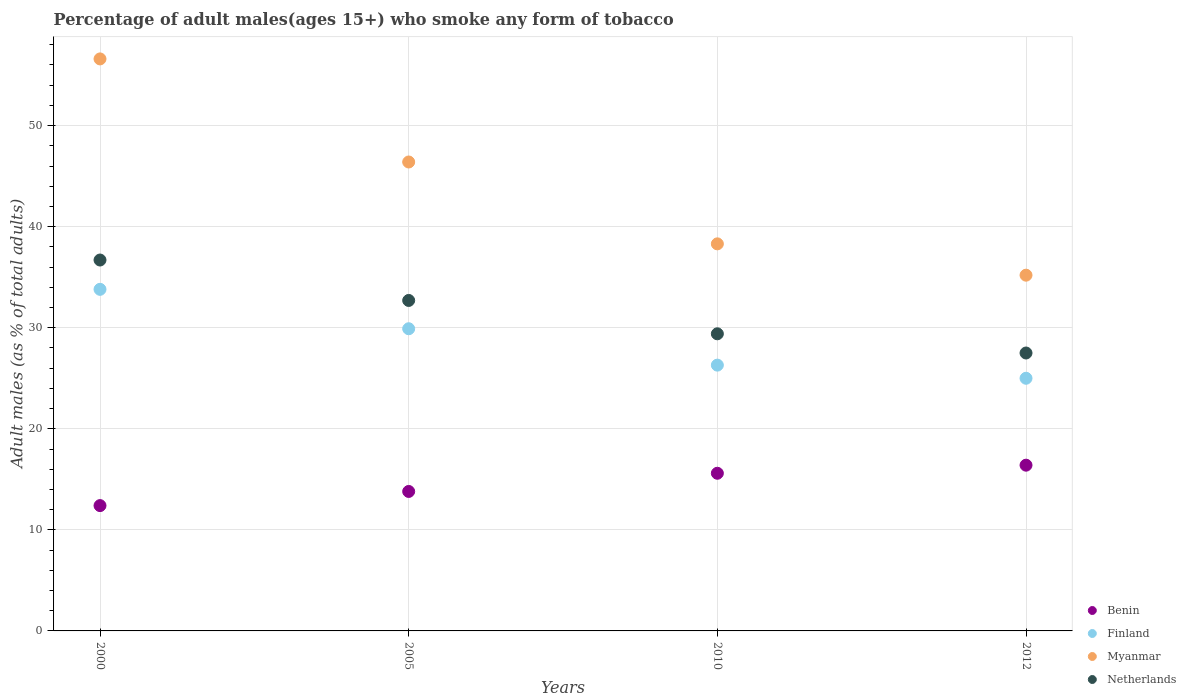How many different coloured dotlines are there?
Your answer should be compact. 4. Is the number of dotlines equal to the number of legend labels?
Give a very brief answer. Yes. What is the percentage of adult males who smoke in Finland in 2005?
Make the answer very short. 29.9. Across all years, what is the maximum percentage of adult males who smoke in Benin?
Your answer should be compact. 16.4. Across all years, what is the minimum percentage of adult males who smoke in Finland?
Offer a terse response. 25. In which year was the percentage of adult males who smoke in Finland minimum?
Provide a short and direct response. 2012. What is the total percentage of adult males who smoke in Finland in the graph?
Your response must be concise. 115. What is the difference between the percentage of adult males who smoke in Myanmar in 2010 and that in 2012?
Offer a terse response. 3.1. What is the difference between the percentage of adult males who smoke in Finland in 2000 and the percentage of adult males who smoke in Myanmar in 2012?
Provide a short and direct response. -1.4. What is the average percentage of adult males who smoke in Netherlands per year?
Your response must be concise. 31.58. In the year 2005, what is the difference between the percentage of adult males who smoke in Benin and percentage of adult males who smoke in Myanmar?
Offer a very short reply. -32.6. In how many years, is the percentage of adult males who smoke in Finland greater than 20 %?
Your response must be concise. 4. What is the ratio of the percentage of adult males who smoke in Netherlands in 2000 to that in 2010?
Your answer should be very brief. 1.25. Is the difference between the percentage of adult males who smoke in Benin in 2000 and 2005 greater than the difference between the percentage of adult males who smoke in Myanmar in 2000 and 2005?
Provide a succinct answer. No. What is the difference between the highest and the second highest percentage of adult males who smoke in Finland?
Provide a succinct answer. 3.9. What is the difference between the highest and the lowest percentage of adult males who smoke in Finland?
Your answer should be compact. 8.8. Is the sum of the percentage of adult males who smoke in Netherlands in 2005 and 2012 greater than the maximum percentage of adult males who smoke in Finland across all years?
Provide a short and direct response. Yes. Does the percentage of adult males who smoke in Netherlands monotonically increase over the years?
Provide a short and direct response. No. How many years are there in the graph?
Give a very brief answer. 4. What is the difference between two consecutive major ticks on the Y-axis?
Your answer should be compact. 10. Are the values on the major ticks of Y-axis written in scientific E-notation?
Keep it short and to the point. No. Where does the legend appear in the graph?
Give a very brief answer. Bottom right. How many legend labels are there?
Your answer should be very brief. 4. What is the title of the graph?
Offer a terse response. Percentage of adult males(ages 15+) who smoke any form of tobacco. What is the label or title of the Y-axis?
Provide a short and direct response. Adult males (as % of total adults). What is the Adult males (as % of total adults) of Finland in 2000?
Provide a succinct answer. 33.8. What is the Adult males (as % of total adults) of Myanmar in 2000?
Provide a succinct answer. 56.6. What is the Adult males (as % of total adults) of Netherlands in 2000?
Ensure brevity in your answer.  36.7. What is the Adult males (as % of total adults) of Finland in 2005?
Provide a short and direct response. 29.9. What is the Adult males (as % of total adults) in Myanmar in 2005?
Ensure brevity in your answer.  46.4. What is the Adult males (as % of total adults) of Netherlands in 2005?
Your answer should be compact. 32.7. What is the Adult males (as % of total adults) of Benin in 2010?
Ensure brevity in your answer.  15.6. What is the Adult males (as % of total adults) in Finland in 2010?
Give a very brief answer. 26.3. What is the Adult males (as % of total adults) in Myanmar in 2010?
Offer a very short reply. 38.3. What is the Adult males (as % of total adults) in Netherlands in 2010?
Offer a terse response. 29.4. What is the Adult males (as % of total adults) in Myanmar in 2012?
Give a very brief answer. 35.2. What is the Adult males (as % of total adults) of Netherlands in 2012?
Keep it short and to the point. 27.5. Across all years, what is the maximum Adult males (as % of total adults) in Finland?
Your answer should be very brief. 33.8. Across all years, what is the maximum Adult males (as % of total adults) of Myanmar?
Keep it short and to the point. 56.6. Across all years, what is the maximum Adult males (as % of total adults) in Netherlands?
Provide a short and direct response. 36.7. Across all years, what is the minimum Adult males (as % of total adults) in Benin?
Your response must be concise. 12.4. Across all years, what is the minimum Adult males (as % of total adults) of Finland?
Provide a short and direct response. 25. Across all years, what is the minimum Adult males (as % of total adults) in Myanmar?
Give a very brief answer. 35.2. What is the total Adult males (as % of total adults) in Benin in the graph?
Provide a short and direct response. 58.2. What is the total Adult males (as % of total adults) of Finland in the graph?
Give a very brief answer. 115. What is the total Adult males (as % of total adults) in Myanmar in the graph?
Ensure brevity in your answer.  176.5. What is the total Adult males (as % of total adults) of Netherlands in the graph?
Make the answer very short. 126.3. What is the difference between the Adult males (as % of total adults) of Finland in 2000 and that in 2005?
Your answer should be compact. 3.9. What is the difference between the Adult males (as % of total adults) of Myanmar in 2000 and that in 2005?
Provide a short and direct response. 10.2. What is the difference between the Adult males (as % of total adults) in Netherlands in 2000 and that in 2005?
Keep it short and to the point. 4. What is the difference between the Adult males (as % of total adults) in Netherlands in 2000 and that in 2010?
Your answer should be very brief. 7.3. What is the difference between the Adult males (as % of total adults) in Myanmar in 2000 and that in 2012?
Offer a very short reply. 21.4. What is the difference between the Adult males (as % of total adults) of Myanmar in 2005 and that in 2010?
Your answer should be very brief. 8.1. What is the difference between the Adult males (as % of total adults) of Benin in 2005 and that in 2012?
Give a very brief answer. -2.6. What is the difference between the Adult males (as % of total adults) in Benin in 2010 and that in 2012?
Your answer should be compact. -0.8. What is the difference between the Adult males (as % of total adults) of Finland in 2010 and that in 2012?
Your answer should be compact. 1.3. What is the difference between the Adult males (as % of total adults) of Netherlands in 2010 and that in 2012?
Make the answer very short. 1.9. What is the difference between the Adult males (as % of total adults) of Benin in 2000 and the Adult males (as % of total adults) of Finland in 2005?
Ensure brevity in your answer.  -17.5. What is the difference between the Adult males (as % of total adults) in Benin in 2000 and the Adult males (as % of total adults) in Myanmar in 2005?
Give a very brief answer. -34. What is the difference between the Adult males (as % of total adults) of Benin in 2000 and the Adult males (as % of total adults) of Netherlands in 2005?
Offer a terse response. -20.3. What is the difference between the Adult males (as % of total adults) in Finland in 2000 and the Adult males (as % of total adults) in Netherlands in 2005?
Keep it short and to the point. 1.1. What is the difference between the Adult males (as % of total adults) of Myanmar in 2000 and the Adult males (as % of total adults) of Netherlands in 2005?
Provide a succinct answer. 23.9. What is the difference between the Adult males (as % of total adults) of Benin in 2000 and the Adult males (as % of total adults) of Myanmar in 2010?
Your answer should be very brief. -25.9. What is the difference between the Adult males (as % of total adults) of Finland in 2000 and the Adult males (as % of total adults) of Myanmar in 2010?
Offer a very short reply. -4.5. What is the difference between the Adult males (as % of total adults) in Finland in 2000 and the Adult males (as % of total adults) in Netherlands in 2010?
Offer a very short reply. 4.4. What is the difference between the Adult males (as % of total adults) of Myanmar in 2000 and the Adult males (as % of total adults) of Netherlands in 2010?
Your answer should be very brief. 27.2. What is the difference between the Adult males (as % of total adults) in Benin in 2000 and the Adult males (as % of total adults) in Myanmar in 2012?
Your response must be concise. -22.8. What is the difference between the Adult males (as % of total adults) of Benin in 2000 and the Adult males (as % of total adults) of Netherlands in 2012?
Your response must be concise. -15.1. What is the difference between the Adult males (as % of total adults) of Finland in 2000 and the Adult males (as % of total adults) of Netherlands in 2012?
Your response must be concise. 6.3. What is the difference between the Adult males (as % of total adults) in Myanmar in 2000 and the Adult males (as % of total adults) in Netherlands in 2012?
Ensure brevity in your answer.  29.1. What is the difference between the Adult males (as % of total adults) in Benin in 2005 and the Adult males (as % of total adults) in Finland in 2010?
Your answer should be very brief. -12.5. What is the difference between the Adult males (as % of total adults) of Benin in 2005 and the Adult males (as % of total adults) of Myanmar in 2010?
Offer a very short reply. -24.5. What is the difference between the Adult males (as % of total adults) in Benin in 2005 and the Adult males (as % of total adults) in Netherlands in 2010?
Your answer should be very brief. -15.6. What is the difference between the Adult males (as % of total adults) of Finland in 2005 and the Adult males (as % of total adults) of Myanmar in 2010?
Give a very brief answer. -8.4. What is the difference between the Adult males (as % of total adults) in Myanmar in 2005 and the Adult males (as % of total adults) in Netherlands in 2010?
Your response must be concise. 17. What is the difference between the Adult males (as % of total adults) of Benin in 2005 and the Adult males (as % of total adults) of Finland in 2012?
Make the answer very short. -11.2. What is the difference between the Adult males (as % of total adults) in Benin in 2005 and the Adult males (as % of total adults) in Myanmar in 2012?
Offer a very short reply. -21.4. What is the difference between the Adult males (as % of total adults) of Benin in 2005 and the Adult males (as % of total adults) of Netherlands in 2012?
Make the answer very short. -13.7. What is the difference between the Adult males (as % of total adults) of Benin in 2010 and the Adult males (as % of total adults) of Myanmar in 2012?
Provide a short and direct response. -19.6. What is the difference between the Adult males (as % of total adults) of Finland in 2010 and the Adult males (as % of total adults) of Myanmar in 2012?
Keep it short and to the point. -8.9. What is the difference between the Adult males (as % of total adults) of Myanmar in 2010 and the Adult males (as % of total adults) of Netherlands in 2012?
Provide a short and direct response. 10.8. What is the average Adult males (as % of total adults) of Benin per year?
Ensure brevity in your answer.  14.55. What is the average Adult males (as % of total adults) in Finland per year?
Offer a very short reply. 28.75. What is the average Adult males (as % of total adults) of Myanmar per year?
Offer a terse response. 44.12. What is the average Adult males (as % of total adults) in Netherlands per year?
Offer a very short reply. 31.57. In the year 2000, what is the difference between the Adult males (as % of total adults) of Benin and Adult males (as % of total adults) of Finland?
Ensure brevity in your answer.  -21.4. In the year 2000, what is the difference between the Adult males (as % of total adults) of Benin and Adult males (as % of total adults) of Myanmar?
Keep it short and to the point. -44.2. In the year 2000, what is the difference between the Adult males (as % of total adults) of Benin and Adult males (as % of total adults) of Netherlands?
Your answer should be compact. -24.3. In the year 2000, what is the difference between the Adult males (as % of total adults) in Finland and Adult males (as % of total adults) in Myanmar?
Your answer should be compact. -22.8. In the year 2000, what is the difference between the Adult males (as % of total adults) of Finland and Adult males (as % of total adults) of Netherlands?
Give a very brief answer. -2.9. In the year 2005, what is the difference between the Adult males (as % of total adults) in Benin and Adult males (as % of total adults) in Finland?
Offer a very short reply. -16.1. In the year 2005, what is the difference between the Adult males (as % of total adults) in Benin and Adult males (as % of total adults) in Myanmar?
Offer a very short reply. -32.6. In the year 2005, what is the difference between the Adult males (as % of total adults) of Benin and Adult males (as % of total adults) of Netherlands?
Ensure brevity in your answer.  -18.9. In the year 2005, what is the difference between the Adult males (as % of total adults) of Finland and Adult males (as % of total adults) of Myanmar?
Your response must be concise. -16.5. In the year 2005, what is the difference between the Adult males (as % of total adults) of Finland and Adult males (as % of total adults) of Netherlands?
Provide a succinct answer. -2.8. In the year 2005, what is the difference between the Adult males (as % of total adults) of Myanmar and Adult males (as % of total adults) of Netherlands?
Your answer should be very brief. 13.7. In the year 2010, what is the difference between the Adult males (as % of total adults) of Benin and Adult males (as % of total adults) of Myanmar?
Ensure brevity in your answer.  -22.7. In the year 2010, what is the difference between the Adult males (as % of total adults) in Finland and Adult males (as % of total adults) in Myanmar?
Offer a terse response. -12. In the year 2010, what is the difference between the Adult males (as % of total adults) of Finland and Adult males (as % of total adults) of Netherlands?
Provide a short and direct response. -3.1. In the year 2012, what is the difference between the Adult males (as % of total adults) of Benin and Adult males (as % of total adults) of Myanmar?
Offer a terse response. -18.8. In the year 2012, what is the difference between the Adult males (as % of total adults) in Finland and Adult males (as % of total adults) in Netherlands?
Offer a terse response. -2.5. What is the ratio of the Adult males (as % of total adults) of Benin in 2000 to that in 2005?
Provide a short and direct response. 0.9. What is the ratio of the Adult males (as % of total adults) in Finland in 2000 to that in 2005?
Offer a very short reply. 1.13. What is the ratio of the Adult males (as % of total adults) of Myanmar in 2000 to that in 2005?
Offer a very short reply. 1.22. What is the ratio of the Adult males (as % of total adults) of Netherlands in 2000 to that in 2005?
Your answer should be compact. 1.12. What is the ratio of the Adult males (as % of total adults) of Benin in 2000 to that in 2010?
Ensure brevity in your answer.  0.79. What is the ratio of the Adult males (as % of total adults) in Finland in 2000 to that in 2010?
Your answer should be compact. 1.29. What is the ratio of the Adult males (as % of total adults) of Myanmar in 2000 to that in 2010?
Provide a succinct answer. 1.48. What is the ratio of the Adult males (as % of total adults) in Netherlands in 2000 to that in 2010?
Your response must be concise. 1.25. What is the ratio of the Adult males (as % of total adults) of Benin in 2000 to that in 2012?
Your answer should be compact. 0.76. What is the ratio of the Adult males (as % of total adults) of Finland in 2000 to that in 2012?
Keep it short and to the point. 1.35. What is the ratio of the Adult males (as % of total adults) of Myanmar in 2000 to that in 2012?
Ensure brevity in your answer.  1.61. What is the ratio of the Adult males (as % of total adults) of Netherlands in 2000 to that in 2012?
Make the answer very short. 1.33. What is the ratio of the Adult males (as % of total adults) in Benin in 2005 to that in 2010?
Give a very brief answer. 0.88. What is the ratio of the Adult males (as % of total adults) in Finland in 2005 to that in 2010?
Provide a succinct answer. 1.14. What is the ratio of the Adult males (as % of total adults) in Myanmar in 2005 to that in 2010?
Give a very brief answer. 1.21. What is the ratio of the Adult males (as % of total adults) of Netherlands in 2005 to that in 2010?
Ensure brevity in your answer.  1.11. What is the ratio of the Adult males (as % of total adults) in Benin in 2005 to that in 2012?
Your response must be concise. 0.84. What is the ratio of the Adult males (as % of total adults) in Finland in 2005 to that in 2012?
Offer a very short reply. 1.2. What is the ratio of the Adult males (as % of total adults) of Myanmar in 2005 to that in 2012?
Offer a very short reply. 1.32. What is the ratio of the Adult males (as % of total adults) in Netherlands in 2005 to that in 2012?
Make the answer very short. 1.19. What is the ratio of the Adult males (as % of total adults) in Benin in 2010 to that in 2012?
Your answer should be compact. 0.95. What is the ratio of the Adult males (as % of total adults) of Finland in 2010 to that in 2012?
Your answer should be compact. 1.05. What is the ratio of the Adult males (as % of total adults) in Myanmar in 2010 to that in 2012?
Provide a succinct answer. 1.09. What is the ratio of the Adult males (as % of total adults) of Netherlands in 2010 to that in 2012?
Your response must be concise. 1.07. What is the difference between the highest and the second highest Adult males (as % of total adults) in Myanmar?
Your response must be concise. 10.2. What is the difference between the highest and the second highest Adult males (as % of total adults) of Netherlands?
Your answer should be compact. 4. What is the difference between the highest and the lowest Adult males (as % of total adults) in Benin?
Your answer should be compact. 4. What is the difference between the highest and the lowest Adult males (as % of total adults) in Myanmar?
Your response must be concise. 21.4. What is the difference between the highest and the lowest Adult males (as % of total adults) of Netherlands?
Offer a very short reply. 9.2. 